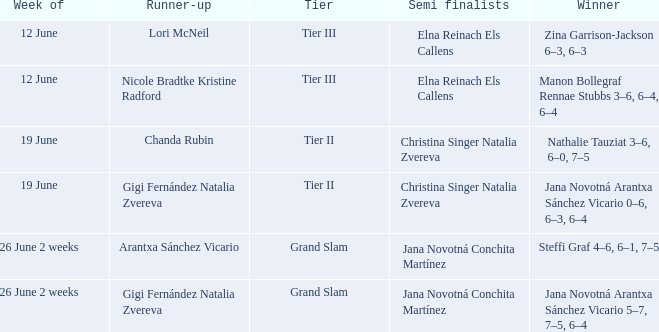When the Tier is listed as tier iii, who is the Winner? Zina Garrison-Jackson 6–3, 6–3, Manon Bollegraf Rennae Stubbs 3–6, 6–4, 6–4. Could you parse the entire table as a dict? {'header': ['Week of', 'Runner-up', 'Tier', 'Semi finalists', 'Winner'], 'rows': [['12 June', 'Lori McNeil', 'Tier III', 'Elna Reinach Els Callens', 'Zina Garrison-Jackson 6–3, 6–3'], ['12 June', 'Nicole Bradtke Kristine Radford', 'Tier III', 'Elna Reinach Els Callens', 'Manon Bollegraf Rennae Stubbs 3–6, 6–4, 6–4'], ['19 June', 'Chanda Rubin', 'Tier II', 'Christina Singer Natalia Zvereva', 'Nathalie Tauziat 3–6, 6–0, 7–5'], ['19 June', 'Gigi Fernández Natalia Zvereva', 'Tier II', 'Christina Singer Natalia Zvereva', 'Jana Novotná Arantxa Sánchez Vicario 0–6, 6–3, 6–4'], ['26 June 2 weeks', 'Arantxa Sánchez Vicario', 'Grand Slam', 'Jana Novotná Conchita Martínez', 'Steffi Graf 4–6, 6–1, 7–5'], ['26 June 2 weeks', 'Gigi Fernández Natalia Zvereva', 'Grand Slam', 'Jana Novotná Conchita Martínez', 'Jana Novotná Arantxa Sánchez Vicario 5–7, 7–5, 6–4']]} 